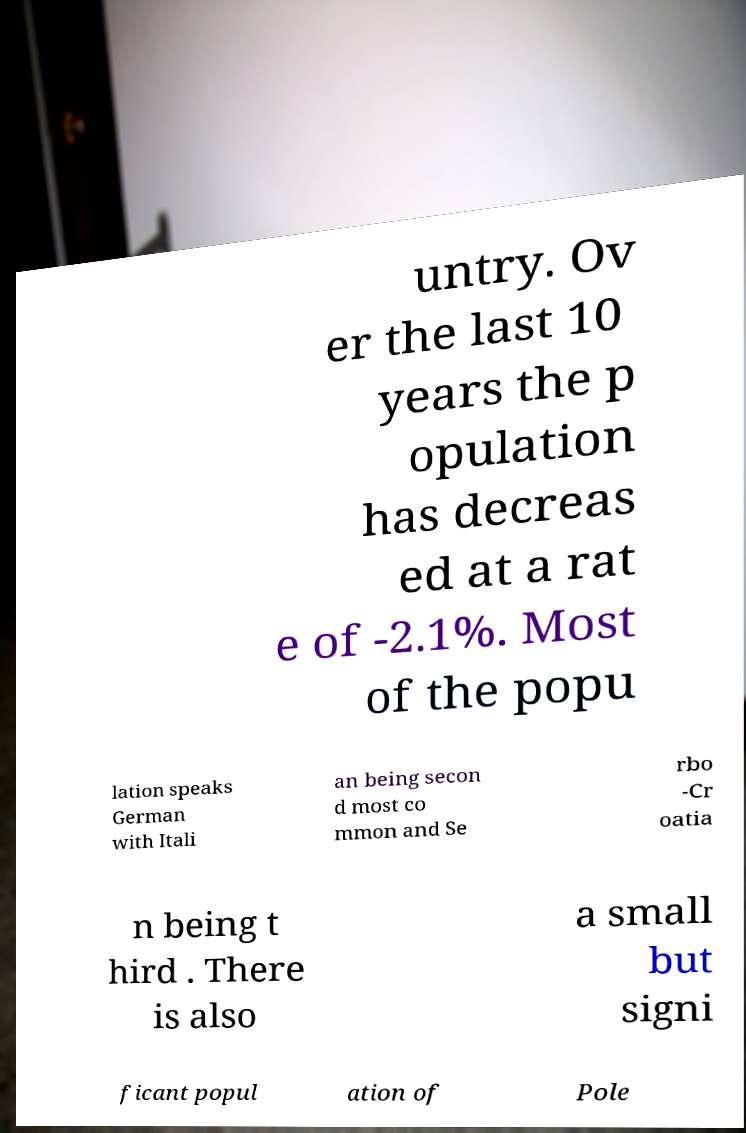There's text embedded in this image that I need extracted. Can you transcribe it verbatim? untry. Ov er the last 10 years the p opulation has decreas ed at a rat e of -2.1%. Most of the popu lation speaks German with Itali an being secon d most co mmon and Se rbo -Cr oatia n being t hird . There is also a small but signi ficant popul ation of Pole 